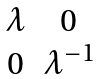Convert formula to latex. <formula><loc_0><loc_0><loc_500><loc_500>\begin{matrix} \lambda & 0 \\ 0 & \lambda ^ { - 1 } \end{matrix}</formula> 